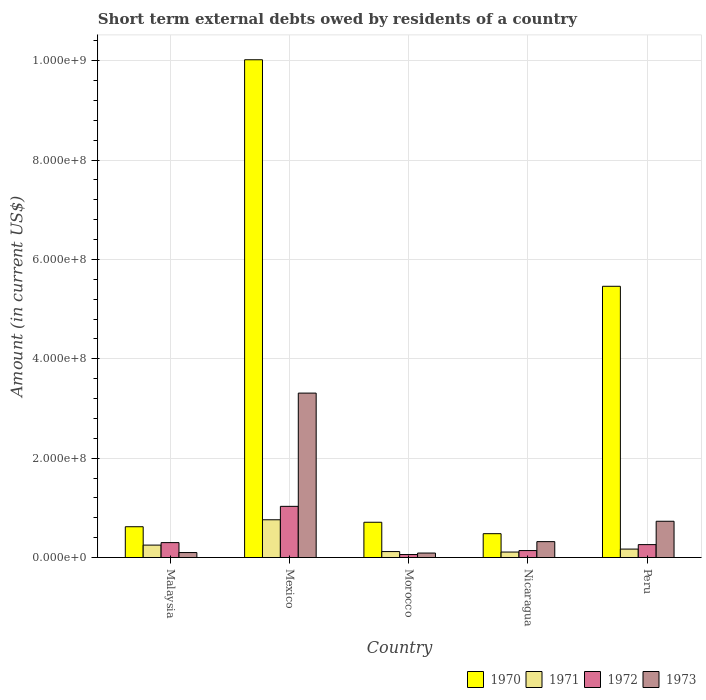How many groups of bars are there?
Give a very brief answer. 5. Are the number of bars per tick equal to the number of legend labels?
Provide a succinct answer. Yes. How many bars are there on the 5th tick from the left?
Your answer should be very brief. 4. How many bars are there on the 2nd tick from the right?
Make the answer very short. 4. In how many cases, is the number of bars for a given country not equal to the number of legend labels?
Make the answer very short. 0. What is the amount of short-term external debts owed by residents in 1971 in Morocco?
Provide a succinct answer. 1.20e+07. Across all countries, what is the maximum amount of short-term external debts owed by residents in 1970?
Offer a very short reply. 1.00e+09. Across all countries, what is the minimum amount of short-term external debts owed by residents in 1972?
Provide a short and direct response. 6.00e+06. In which country was the amount of short-term external debts owed by residents in 1973 minimum?
Provide a short and direct response. Morocco. What is the total amount of short-term external debts owed by residents in 1970 in the graph?
Offer a very short reply. 1.73e+09. What is the difference between the amount of short-term external debts owed by residents in 1972 in Nicaragua and that in Peru?
Provide a succinct answer. -1.20e+07. What is the difference between the amount of short-term external debts owed by residents in 1972 in Mexico and the amount of short-term external debts owed by residents in 1971 in Peru?
Ensure brevity in your answer.  8.60e+07. What is the average amount of short-term external debts owed by residents in 1973 per country?
Provide a short and direct response. 9.10e+07. What is the difference between the amount of short-term external debts owed by residents of/in 1973 and amount of short-term external debts owed by residents of/in 1972 in Nicaragua?
Your response must be concise. 1.80e+07. In how many countries, is the amount of short-term external debts owed by residents in 1971 greater than 280000000 US$?
Your answer should be compact. 0. What is the ratio of the amount of short-term external debts owed by residents in 1973 in Malaysia to that in Morocco?
Keep it short and to the point. 1.11. Is the difference between the amount of short-term external debts owed by residents in 1973 in Mexico and Peru greater than the difference between the amount of short-term external debts owed by residents in 1972 in Mexico and Peru?
Provide a succinct answer. Yes. What is the difference between the highest and the second highest amount of short-term external debts owed by residents in 1971?
Ensure brevity in your answer.  5.90e+07. What is the difference between the highest and the lowest amount of short-term external debts owed by residents in 1972?
Provide a short and direct response. 9.70e+07. Is the sum of the amount of short-term external debts owed by residents in 1970 in Morocco and Nicaragua greater than the maximum amount of short-term external debts owed by residents in 1973 across all countries?
Keep it short and to the point. No. What does the 2nd bar from the right in Malaysia represents?
Your response must be concise. 1972. Is it the case that in every country, the sum of the amount of short-term external debts owed by residents in 1971 and amount of short-term external debts owed by residents in 1972 is greater than the amount of short-term external debts owed by residents in 1970?
Make the answer very short. No. How many bars are there?
Provide a succinct answer. 20. How many countries are there in the graph?
Your response must be concise. 5. Are the values on the major ticks of Y-axis written in scientific E-notation?
Provide a short and direct response. Yes. Does the graph contain any zero values?
Ensure brevity in your answer.  No. Does the graph contain grids?
Give a very brief answer. Yes. Where does the legend appear in the graph?
Make the answer very short. Bottom right. What is the title of the graph?
Provide a succinct answer. Short term external debts owed by residents of a country. Does "2001" appear as one of the legend labels in the graph?
Offer a very short reply. No. What is the label or title of the Y-axis?
Ensure brevity in your answer.  Amount (in current US$). What is the Amount (in current US$) in 1970 in Malaysia?
Provide a succinct answer. 6.20e+07. What is the Amount (in current US$) in 1971 in Malaysia?
Give a very brief answer. 2.50e+07. What is the Amount (in current US$) in 1972 in Malaysia?
Provide a succinct answer. 3.00e+07. What is the Amount (in current US$) in 1973 in Malaysia?
Your answer should be compact. 1.00e+07. What is the Amount (in current US$) of 1970 in Mexico?
Offer a terse response. 1.00e+09. What is the Amount (in current US$) in 1971 in Mexico?
Your answer should be compact. 7.60e+07. What is the Amount (in current US$) in 1972 in Mexico?
Offer a terse response. 1.03e+08. What is the Amount (in current US$) of 1973 in Mexico?
Your answer should be very brief. 3.31e+08. What is the Amount (in current US$) in 1970 in Morocco?
Offer a very short reply. 7.10e+07. What is the Amount (in current US$) of 1973 in Morocco?
Your answer should be very brief. 9.00e+06. What is the Amount (in current US$) of 1970 in Nicaragua?
Your answer should be very brief. 4.80e+07. What is the Amount (in current US$) in 1971 in Nicaragua?
Offer a terse response. 1.10e+07. What is the Amount (in current US$) of 1972 in Nicaragua?
Your answer should be compact. 1.40e+07. What is the Amount (in current US$) in 1973 in Nicaragua?
Make the answer very short. 3.20e+07. What is the Amount (in current US$) of 1970 in Peru?
Give a very brief answer. 5.46e+08. What is the Amount (in current US$) of 1971 in Peru?
Provide a short and direct response. 1.70e+07. What is the Amount (in current US$) in 1972 in Peru?
Keep it short and to the point. 2.60e+07. What is the Amount (in current US$) in 1973 in Peru?
Make the answer very short. 7.30e+07. Across all countries, what is the maximum Amount (in current US$) in 1970?
Your response must be concise. 1.00e+09. Across all countries, what is the maximum Amount (in current US$) of 1971?
Make the answer very short. 7.60e+07. Across all countries, what is the maximum Amount (in current US$) in 1972?
Your response must be concise. 1.03e+08. Across all countries, what is the maximum Amount (in current US$) of 1973?
Offer a very short reply. 3.31e+08. Across all countries, what is the minimum Amount (in current US$) of 1970?
Make the answer very short. 4.80e+07. Across all countries, what is the minimum Amount (in current US$) of 1971?
Your answer should be very brief. 1.10e+07. Across all countries, what is the minimum Amount (in current US$) in 1973?
Offer a terse response. 9.00e+06. What is the total Amount (in current US$) of 1970 in the graph?
Provide a short and direct response. 1.73e+09. What is the total Amount (in current US$) in 1971 in the graph?
Offer a very short reply. 1.41e+08. What is the total Amount (in current US$) in 1972 in the graph?
Your answer should be compact. 1.79e+08. What is the total Amount (in current US$) of 1973 in the graph?
Provide a short and direct response. 4.55e+08. What is the difference between the Amount (in current US$) of 1970 in Malaysia and that in Mexico?
Your answer should be very brief. -9.40e+08. What is the difference between the Amount (in current US$) in 1971 in Malaysia and that in Mexico?
Make the answer very short. -5.10e+07. What is the difference between the Amount (in current US$) in 1972 in Malaysia and that in Mexico?
Keep it short and to the point. -7.30e+07. What is the difference between the Amount (in current US$) in 1973 in Malaysia and that in Mexico?
Offer a terse response. -3.21e+08. What is the difference between the Amount (in current US$) in 1970 in Malaysia and that in Morocco?
Provide a short and direct response. -9.00e+06. What is the difference between the Amount (in current US$) in 1971 in Malaysia and that in Morocco?
Give a very brief answer. 1.30e+07. What is the difference between the Amount (in current US$) of 1972 in Malaysia and that in Morocco?
Offer a terse response. 2.40e+07. What is the difference between the Amount (in current US$) of 1973 in Malaysia and that in Morocco?
Keep it short and to the point. 1.00e+06. What is the difference between the Amount (in current US$) in 1970 in Malaysia and that in Nicaragua?
Provide a short and direct response. 1.40e+07. What is the difference between the Amount (in current US$) in 1971 in Malaysia and that in Nicaragua?
Your answer should be compact. 1.40e+07. What is the difference between the Amount (in current US$) of 1972 in Malaysia and that in Nicaragua?
Your answer should be very brief. 1.60e+07. What is the difference between the Amount (in current US$) of 1973 in Malaysia and that in Nicaragua?
Your answer should be very brief. -2.20e+07. What is the difference between the Amount (in current US$) in 1970 in Malaysia and that in Peru?
Make the answer very short. -4.84e+08. What is the difference between the Amount (in current US$) in 1971 in Malaysia and that in Peru?
Provide a short and direct response. 8.00e+06. What is the difference between the Amount (in current US$) in 1972 in Malaysia and that in Peru?
Offer a terse response. 4.00e+06. What is the difference between the Amount (in current US$) of 1973 in Malaysia and that in Peru?
Your answer should be very brief. -6.30e+07. What is the difference between the Amount (in current US$) in 1970 in Mexico and that in Morocco?
Give a very brief answer. 9.31e+08. What is the difference between the Amount (in current US$) in 1971 in Mexico and that in Morocco?
Offer a very short reply. 6.40e+07. What is the difference between the Amount (in current US$) in 1972 in Mexico and that in Morocco?
Provide a succinct answer. 9.70e+07. What is the difference between the Amount (in current US$) of 1973 in Mexico and that in Morocco?
Offer a very short reply. 3.22e+08. What is the difference between the Amount (in current US$) of 1970 in Mexico and that in Nicaragua?
Make the answer very short. 9.54e+08. What is the difference between the Amount (in current US$) in 1971 in Mexico and that in Nicaragua?
Give a very brief answer. 6.50e+07. What is the difference between the Amount (in current US$) in 1972 in Mexico and that in Nicaragua?
Your answer should be very brief. 8.90e+07. What is the difference between the Amount (in current US$) in 1973 in Mexico and that in Nicaragua?
Offer a very short reply. 2.99e+08. What is the difference between the Amount (in current US$) of 1970 in Mexico and that in Peru?
Provide a succinct answer. 4.56e+08. What is the difference between the Amount (in current US$) in 1971 in Mexico and that in Peru?
Make the answer very short. 5.90e+07. What is the difference between the Amount (in current US$) in 1972 in Mexico and that in Peru?
Provide a succinct answer. 7.70e+07. What is the difference between the Amount (in current US$) of 1973 in Mexico and that in Peru?
Give a very brief answer. 2.58e+08. What is the difference between the Amount (in current US$) of 1970 in Morocco and that in Nicaragua?
Make the answer very short. 2.30e+07. What is the difference between the Amount (in current US$) of 1971 in Morocco and that in Nicaragua?
Make the answer very short. 1.00e+06. What is the difference between the Amount (in current US$) in 1972 in Morocco and that in Nicaragua?
Provide a succinct answer. -8.00e+06. What is the difference between the Amount (in current US$) in 1973 in Morocco and that in Nicaragua?
Provide a short and direct response. -2.30e+07. What is the difference between the Amount (in current US$) of 1970 in Morocco and that in Peru?
Ensure brevity in your answer.  -4.75e+08. What is the difference between the Amount (in current US$) in 1971 in Morocco and that in Peru?
Make the answer very short. -5.00e+06. What is the difference between the Amount (in current US$) in 1972 in Morocco and that in Peru?
Offer a very short reply. -2.00e+07. What is the difference between the Amount (in current US$) in 1973 in Morocco and that in Peru?
Your answer should be very brief. -6.40e+07. What is the difference between the Amount (in current US$) of 1970 in Nicaragua and that in Peru?
Provide a short and direct response. -4.98e+08. What is the difference between the Amount (in current US$) in 1971 in Nicaragua and that in Peru?
Your answer should be very brief. -6.00e+06. What is the difference between the Amount (in current US$) of 1972 in Nicaragua and that in Peru?
Offer a terse response. -1.20e+07. What is the difference between the Amount (in current US$) in 1973 in Nicaragua and that in Peru?
Your response must be concise. -4.10e+07. What is the difference between the Amount (in current US$) of 1970 in Malaysia and the Amount (in current US$) of 1971 in Mexico?
Your answer should be compact. -1.40e+07. What is the difference between the Amount (in current US$) in 1970 in Malaysia and the Amount (in current US$) in 1972 in Mexico?
Provide a succinct answer. -4.10e+07. What is the difference between the Amount (in current US$) of 1970 in Malaysia and the Amount (in current US$) of 1973 in Mexico?
Ensure brevity in your answer.  -2.69e+08. What is the difference between the Amount (in current US$) of 1971 in Malaysia and the Amount (in current US$) of 1972 in Mexico?
Make the answer very short. -7.80e+07. What is the difference between the Amount (in current US$) in 1971 in Malaysia and the Amount (in current US$) in 1973 in Mexico?
Offer a very short reply. -3.06e+08. What is the difference between the Amount (in current US$) in 1972 in Malaysia and the Amount (in current US$) in 1973 in Mexico?
Your answer should be very brief. -3.01e+08. What is the difference between the Amount (in current US$) in 1970 in Malaysia and the Amount (in current US$) in 1972 in Morocco?
Your answer should be very brief. 5.60e+07. What is the difference between the Amount (in current US$) of 1970 in Malaysia and the Amount (in current US$) of 1973 in Morocco?
Your answer should be very brief. 5.30e+07. What is the difference between the Amount (in current US$) of 1971 in Malaysia and the Amount (in current US$) of 1972 in Morocco?
Ensure brevity in your answer.  1.90e+07. What is the difference between the Amount (in current US$) of 1971 in Malaysia and the Amount (in current US$) of 1973 in Morocco?
Offer a very short reply. 1.60e+07. What is the difference between the Amount (in current US$) of 1972 in Malaysia and the Amount (in current US$) of 1973 in Morocco?
Your answer should be very brief. 2.10e+07. What is the difference between the Amount (in current US$) of 1970 in Malaysia and the Amount (in current US$) of 1971 in Nicaragua?
Ensure brevity in your answer.  5.10e+07. What is the difference between the Amount (in current US$) of 1970 in Malaysia and the Amount (in current US$) of 1972 in Nicaragua?
Your answer should be very brief. 4.80e+07. What is the difference between the Amount (in current US$) in 1970 in Malaysia and the Amount (in current US$) in 1973 in Nicaragua?
Your response must be concise. 3.00e+07. What is the difference between the Amount (in current US$) of 1971 in Malaysia and the Amount (in current US$) of 1972 in Nicaragua?
Offer a very short reply. 1.10e+07. What is the difference between the Amount (in current US$) of 1971 in Malaysia and the Amount (in current US$) of 1973 in Nicaragua?
Provide a succinct answer. -7.00e+06. What is the difference between the Amount (in current US$) of 1970 in Malaysia and the Amount (in current US$) of 1971 in Peru?
Provide a succinct answer. 4.50e+07. What is the difference between the Amount (in current US$) of 1970 in Malaysia and the Amount (in current US$) of 1972 in Peru?
Ensure brevity in your answer.  3.60e+07. What is the difference between the Amount (in current US$) of 1970 in Malaysia and the Amount (in current US$) of 1973 in Peru?
Provide a short and direct response. -1.10e+07. What is the difference between the Amount (in current US$) in 1971 in Malaysia and the Amount (in current US$) in 1972 in Peru?
Give a very brief answer. -1.00e+06. What is the difference between the Amount (in current US$) in 1971 in Malaysia and the Amount (in current US$) in 1973 in Peru?
Ensure brevity in your answer.  -4.80e+07. What is the difference between the Amount (in current US$) of 1972 in Malaysia and the Amount (in current US$) of 1973 in Peru?
Your answer should be compact. -4.30e+07. What is the difference between the Amount (in current US$) in 1970 in Mexico and the Amount (in current US$) in 1971 in Morocco?
Give a very brief answer. 9.90e+08. What is the difference between the Amount (in current US$) in 1970 in Mexico and the Amount (in current US$) in 1972 in Morocco?
Your answer should be compact. 9.96e+08. What is the difference between the Amount (in current US$) of 1970 in Mexico and the Amount (in current US$) of 1973 in Morocco?
Give a very brief answer. 9.93e+08. What is the difference between the Amount (in current US$) of 1971 in Mexico and the Amount (in current US$) of 1972 in Morocco?
Your response must be concise. 7.00e+07. What is the difference between the Amount (in current US$) in 1971 in Mexico and the Amount (in current US$) in 1973 in Morocco?
Your answer should be very brief. 6.70e+07. What is the difference between the Amount (in current US$) of 1972 in Mexico and the Amount (in current US$) of 1973 in Morocco?
Give a very brief answer. 9.40e+07. What is the difference between the Amount (in current US$) in 1970 in Mexico and the Amount (in current US$) in 1971 in Nicaragua?
Make the answer very short. 9.91e+08. What is the difference between the Amount (in current US$) of 1970 in Mexico and the Amount (in current US$) of 1972 in Nicaragua?
Ensure brevity in your answer.  9.88e+08. What is the difference between the Amount (in current US$) of 1970 in Mexico and the Amount (in current US$) of 1973 in Nicaragua?
Ensure brevity in your answer.  9.70e+08. What is the difference between the Amount (in current US$) of 1971 in Mexico and the Amount (in current US$) of 1972 in Nicaragua?
Give a very brief answer. 6.20e+07. What is the difference between the Amount (in current US$) in 1971 in Mexico and the Amount (in current US$) in 1973 in Nicaragua?
Offer a terse response. 4.40e+07. What is the difference between the Amount (in current US$) of 1972 in Mexico and the Amount (in current US$) of 1973 in Nicaragua?
Your response must be concise. 7.10e+07. What is the difference between the Amount (in current US$) in 1970 in Mexico and the Amount (in current US$) in 1971 in Peru?
Ensure brevity in your answer.  9.85e+08. What is the difference between the Amount (in current US$) of 1970 in Mexico and the Amount (in current US$) of 1972 in Peru?
Provide a succinct answer. 9.76e+08. What is the difference between the Amount (in current US$) of 1970 in Mexico and the Amount (in current US$) of 1973 in Peru?
Provide a short and direct response. 9.29e+08. What is the difference between the Amount (in current US$) of 1971 in Mexico and the Amount (in current US$) of 1973 in Peru?
Provide a succinct answer. 3.00e+06. What is the difference between the Amount (in current US$) of 1972 in Mexico and the Amount (in current US$) of 1973 in Peru?
Provide a succinct answer. 3.00e+07. What is the difference between the Amount (in current US$) of 1970 in Morocco and the Amount (in current US$) of 1971 in Nicaragua?
Your answer should be very brief. 6.00e+07. What is the difference between the Amount (in current US$) of 1970 in Morocco and the Amount (in current US$) of 1972 in Nicaragua?
Provide a short and direct response. 5.70e+07. What is the difference between the Amount (in current US$) in 1970 in Morocco and the Amount (in current US$) in 1973 in Nicaragua?
Your answer should be compact. 3.90e+07. What is the difference between the Amount (in current US$) in 1971 in Morocco and the Amount (in current US$) in 1973 in Nicaragua?
Your answer should be compact. -2.00e+07. What is the difference between the Amount (in current US$) in 1972 in Morocco and the Amount (in current US$) in 1973 in Nicaragua?
Your response must be concise. -2.60e+07. What is the difference between the Amount (in current US$) of 1970 in Morocco and the Amount (in current US$) of 1971 in Peru?
Provide a succinct answer. 5.40e+07. What is the difference between the Amount (in current US$) of 1970 in Morocco and the Amount (in current US$) of 1972 in Peru?
Your response must be concise. 4.50e+07. What is the difference between the Amount (in current US$) in 1970 in Morocco and the Amount (in current US$) in 1973 in Peru?
Provide a short and direct response. -2.00e+06. What is the difference between the Amount (in current US$) of 1971 in Morocco and the Amount (in current US$) of 1972 in Peru?
Offer a terse response. -1.40e+07. What is the difference between the Amount (in current US$) in 1971 in Morocco and the Amount (in current US$) in 1973 in Peru?
Offer a terse response. -6.10e+07. What is the difference between the Amount (in current US$) of 1972 in Morocco and the Amount (in current US$) of 1973 in Peru?
Your response must be concise. -6.70e+07. What is the difference between the Amount (in current US$) of 1970 in Nicaragua and the Amount (in current US$) of 1971 in Peru?
Provide a succinct answer. 3.10e+07. What is the difference between the Amount (in current US$) in 1970 in Nicaragua and the Amount (in current US$) in 1972 in Peru?
Make the answer very short. 2.20e+07. What is the difference between the Amount (in current US$) in 1970 in Nicaragua and the Amount (in current US$) in 1973 in Peru?
Make the answer very short. -2.50e+07. What is the difference between the Amount (in current US$) of 1971 in Nicaragua and the Amount (in current US$) of 1972 in Peru?
Ensure brevity in your answer.  -1.50e+07. What is the difference between the Amount (in current US$) in 1971 in Nicaragua and the Amount (in current US$) in 1973 in Peru?
Your response must be concise. -6.20e+07. What is the difference between the Amount (in current US$) in 1972 in Nicaragua and the Amount (in current US$) in 1973 in Peru?
Offer a very short reply. -5.90e+07. What is the average Amount (in current US$) of 1970 per country?
Keep it short and to the point. 3.46e+08. What is the average Amount (in current US$) of 1971 per country?
Give a very brief answer. 2.82e+07. What is the average Amount (in current US$) in 1972 per country?
Your answer should be very brief. 3.58e+07. What is the average Amount (in current US$) in 1973 per country?
Your answer should be compact. 9.10e+07. What is the difference between the Amount (in current US$) of 1970 and Amount (in current US$) of 1971 in Malaysia?
Provide a short and direct response. 3.70e+07. What is the difference between the Amount (in current US$) in 1970 and Amount (in current US$) in 1972 in Malaysia?
Give a very brief answer. 3.20e+07. What is the difference between the Amount (in current US$) in 1970 and Amount (in current US$) in 1973 in Malaysia?
Keep it short and to the point. 5.20e+07. What is the difference between the Amount (in current US$) in 1971 and Amount (in current US$) in 1972 in Malaysia?
Your answer should be compact. -5.00e+06. What is the difference between the Amount (in current US$) in 1971 and Amount (in current US$) in 1973 in Malaysia?
Ensure brevity in your answer.  1.50e+07. What is the difference between the Amount (in current US$) in 1970 and Amount (in current US$) in 1971 in Mexico?
Provide a succinct answer. 9.26e+08. What is the difference between the Amount (in current US$) in 1970 and Amount (in current US$) in 1972 in Mexico?
Offer a terse response. 8.99e+08. What is the difference between the Amount (in current US$) in 1970 and Amount (in current US$) in 1973 in Mexico?
Your answer should be very brief. 6.71e+08. What is the difference between the Amount (in current US$) in 1971 and Amount (in current US$) in 1972 in Mexico?
Provide a succinct answer. -2.70e+07. What is the difference between the Amount (in current US$) of 1971 and Amount (in current US$) of 1973 in Mexico?
Keep it short and to the point. -2.55e+08. What is the difference between the Amount (in current US$) in 1972 and Amount (in current US$) in 1973 in Mexico?
Provide a short and direct response. -2.28e+08. What is the difference between the Amount (in current US$) in 1970 and Amount (in current US$) in 1971 in Morocco?
Provide a succinct answer. 5.90e+07. What is the difference between the Amount (in current US$) in 1970 and Amount (in current US$) in 1972 in Morocco?
Your answer should be very brief. 6.50e+07. What is the difference between the Amount (in current US$) in 1970 and Amount (in current US$) in 1973 in Morocco?
Give a very brief answer. 6.20e+07. What is the difference between the Amount (in current US$) in 1971 and Amount (in current US$) in 1972 in Morocco?
Your answer should be compact. 6.00e+06. What is the difference between the Amount (in current US$) in 1970 and Amount (in current US$) in 1971 in Nicaragua?
Offer a very short reply. 3.70e+07. What is the difference between the Amount (in current US$) in 1970 and Amount (in current US$) in 1972 in Nicaragua?
Make the answer very short. 3.40e+07. What is the difference between the Amount (in current US$) in 1970 and Amount (in current US$) in 1973 in Nicaragua?
Make the answer very short. 1.60e+07. What is the difference between the Amount (in current US$) of 1971 and Amount (in current US$) of 1972 in Nicaragua?
Your response must be concise. -3.00e+06. What is the difference between the Amount (in current US$) in 1971 and Amount (in current US$) in 1973 in Nicaragua?
Provide a succinct answer. -2.10e+07. What is the difference between the Amount (in current US$) of 1972 and Amount (in current US$) of 1973 in Nicaragua?
Give a very brief answer. -1.80e+07. What is the difference between the Amount (in current US$) in 1970 and Amount (in current US$) in 1971 in Peru?
Provide a succinct answer. 5.29e+08. What is the difference between the Amount (in current US$) in 1970 and Amount (in current US$) in 1972 in Peru?
Your answer should be very brief. 5.20e+08. What is the difference between the Amount (in current US$) in 1970 and Amount (in current US$) in 1973 in Peru?
Keep it short and to the point. 4.73e+08. What is the difference between the Amount (in current US$) of 1971 and Amount (in current US$) of 1972 in Peru?
Ensure brevity in your answer.  -9.00e+06. What is the difference between the Amount (in current US$) of 1971 and Amount (in current US$) of 1973 in Peru?
Your response must be concise. -5.60e+07. What is the difference between the Amount (in current US$) in 1972 and Amount (in current US$) in 1973 in Peru?
Your answer should be compact. -4.70e+07. What is the ratio of the Amount (in current US$) in 1970 in Malaysia to that in Mexico?
Ensure brevity in your answer.  0.06. What is the ratio of the Amount (in current US$) in 1971 in Malaysia to that in Mexico?
Your answer should be very brief. 0.33. What is the ratio of the Amount (in current US$) of 1972 in Malaysia to that in Mexico?
Your answer should be compact. 0.29. What is the ratio of the Amount (in current US$) of 1973 in Malaysia to that in Mexico?
Provide a succinct answer. 0.03. What is the ratio of the Amount (in current US$) of 1970 in Malaysia to that in Morocco?
Provide a succinct answer. 0.87. What is the ratio of the Amount (in current US$) in 1971 in Malaysia to that in Morocco?
Ensure brevity in your answer.  2.08. What is the ratio of the Amount (in current US$) of 1973 in Malaysia to that in Morocco?
Keep it short and to the point. 1.11. What is the ratio of the Amount (in current US$) in 1970 in Malaysia to that in Nicaragua?
Your response must be concise. 1.29. What is the ratio of the Amount (in current US$) of 1971 in Malaysia to that in Nicaragua?
Your answer should be very brief. 2.27. What is the ratio of the Amount (in current US$) in 1972 in Malaysia to that in Nicaragua?
Offer a very short reply. 2.14. What is the ratio of the Amount (in current US$) in 1973 in Malaysia to that in Nicaragua?
Give a very brief answer. 0.31. What is the ratio of the Amount (in current US$) of 1970 in Malaysia to that in Peru?
Make the answer very short. 0.11. What is the ratio of the Amount (in current US$) in 1971 in Malaysia to that in Peru?
Give a very brief answer. 1.47. What is the ratio of the Amount (in current US$) in 1972 in Malaysia to that in Peru?
Ensure brevity in your answer.  1.15. What is the ratio of the Amount (in current US$) of 1973 in Malaysia to that in Peru?
Offer a terse response. 0.14. What is the ratio of the Amount (in current US$) of 1970 in Mexico to that in Morocco?
Provide a succinct answer. 14.11. What is the ratio of the Amount (in current US$) of 1971 in Mexico to that in Morocco?
Provide a short and direct response. 6.33. What is the ratio of the Amount (in current US$) in 1972 in Mexico to that in Morocco?
Your answer should be compact. 17.17. What is the ratio of the Amount (in current US$) of 1973 in Mexico to that in Morocco?
Give a very brief answer. 36.78. What is the ratio of the Amount (in current US$) in 1970 in Mexico to that in Nicaragua?
Keep it short and to the point. 20.88. What is the ratio of the Amount (in current US$) in 1971 in Mexico to that in Nicaragua?
Your answer should be very brief. 6.91. What is the ratio of the Amount (in current US$) in 1972 in Mexico to that in Nicaragua?
Your answer should be compact. 7.36. What is the ratio of the Amount (in current US$) of 1973 in Mexico to that in Nicaragua?
Your response must be concise. 10.34. What is the ratio of the Amount (in current US$) in 1970 in Mexico to that in Peru?
Make the answer very short. 1.84. What is the ratio of the Amount (in current US$) in 1971 in Mexico to that in Peru?
Your answer should be compact. 4.47. What is the ratio of the Amount (in current US$) in 1972 in Mexico to that in Peru?
Your response must be concise. 3.96. What is the ratio of the Amount (in current US$) in 1973 in Mexico to that in Peru?
Provide a succinct answer. 4.53. What is the ratio of the Amount (in current US$) in 1970 in Morocco to that in Nicaragua?
Your answer should be compact. 1.48. What is the ratio of the Amount (in current US$) in 1971 in Morocco to that in Nicaragua?
Your answer should be compact. 1.09. What is the ratio of the Amount (in current US$) in 1972 in Morocco to that in Nicaragua?
Offer a very short reply. 0.43. What is the ratio of the Amount (in current US$) of 1973 in Morocco to that in Nicaragua?
Offer a very short reply. 0.28. What is the ratio of the Amount (in current US$) in 1970 in Morocco to that in Peru?
Make the answer very short. 0.13. What is the ratio of the Amount (in current US$) in 1971 in Morocco to that in Peru?
Provide a succinct answer. 0.71. What is the ratio of the Amount (in current US$) of 1972 in Morocco to that in Peru?
Provide a short and direct response. 0.23. What is the ratio of the Amount (in current US$) of 1973 in Morocco to that in Peru?
Keep it short and to the point. 0.12. What is the ratio of the Amount (in current US$) of 1970 in Nicaragua to that in Peru?
Your answer should be very brief. 0.09. What is the ratio of the Amount (in current US$) in 1971 in Nicaragua to that in Peru?
Keep it short and to the point. 0.65. What is the ratio of the Amount (in current US$) of 1972 in Nicaragua to that in Peru?
Offer a terse response. 0.54. What is the ratio of the Amount (in current US$) of 1973 in Nicaragua to that in Peru?
Make the answer very short. 0.44. What is the difference between the highest and the second highest Amount (in current US$) in 1970?
Your answer should be very brief. 4.56e+08. What is the difference between the highest and the second highest Amount (in current US$) in 1971?
Your answer should be very brief. 5.10e+07. What is the difference between the highest and the second highest Amount (in current US$) in 1972?
Your response must be concise. 7.30e+07. What is the difference between the highest and the second highest Amount (in current US$) in 1973?
Give a very brief answer. 2.58e+08. What is the difference between the highest and the lowest Amount (in current US$) of 1970?
Provide a short and direct response. 9.54e+08. What is the difference between the highest and the lowest Amount (in current US$) in 1971?
Your answer should be very brief. 6.50e+07. What is the difference between the highest and the lowest Amount (in current US$) in 1972?
Make the answer very short. 9.70e+07. What is the difference between the highest and the lowest Amount (in current US$) in 1973?
Offer a very short reply. 3.22e+08. 